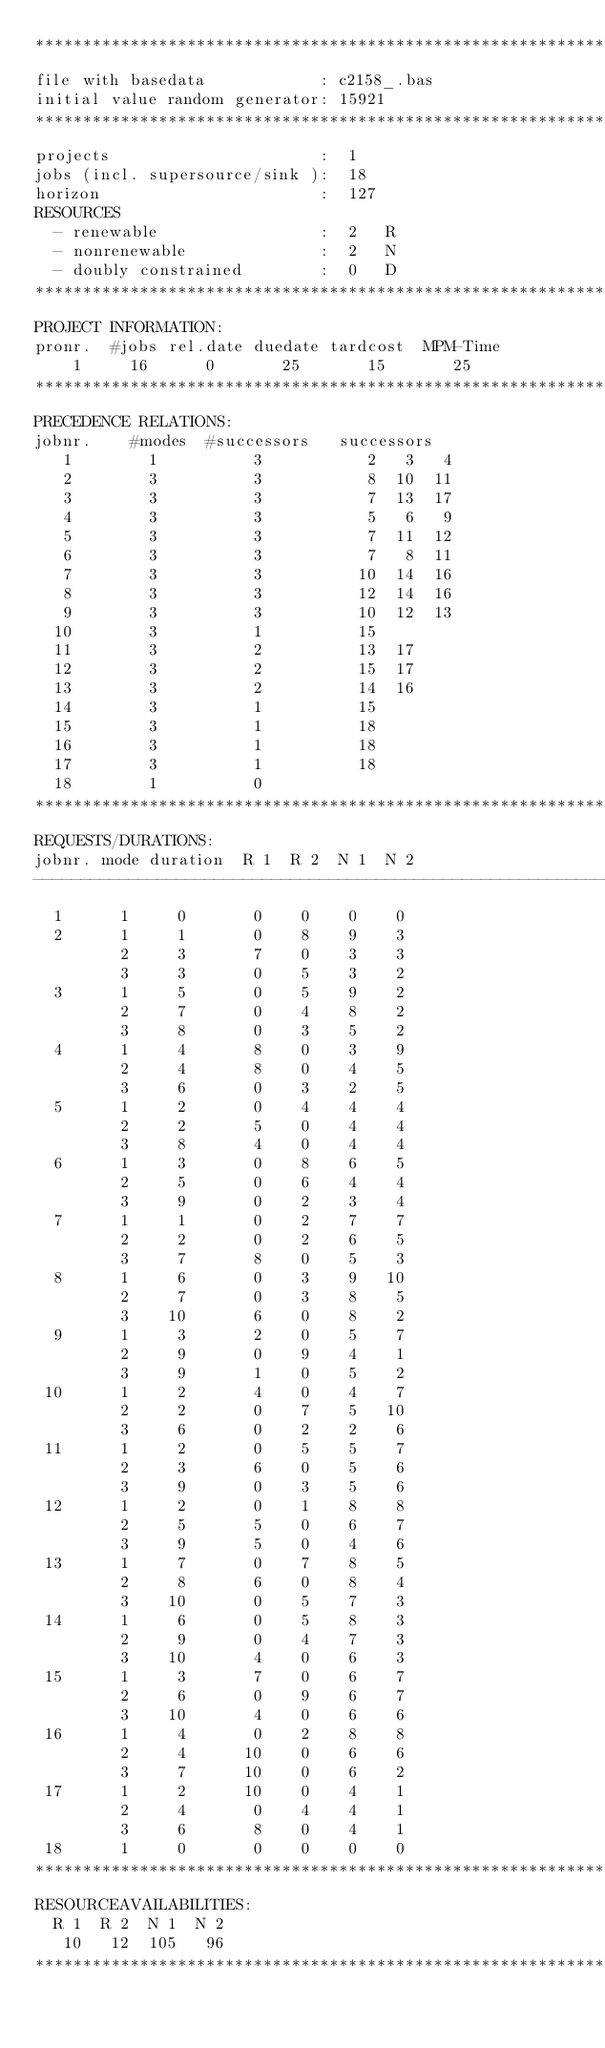Convert code to text. <code><loc_0><loc_0><loc_500><loc_500><_ObjectiveC_>************************************************************************
file with basedata            : c2158_.bas
initial value random generator: 15921
************************************************************************
projects                      :  1
jobs (incl. supersource/sink ):  18
horizon                       :  127
RESOURCES
  - renewable                 :  2   R
  - nonrenewable              :  2   N
  - doubly constrained        :  0   D
************************************************************************
PROJECT INFORMATION:
pronr.  #jobs rel.date duedate tardcost  MPM-Time
    1     16      0       25       15       25
************************************************************************
PRECEDENCE RELATIONS:
jobnr.    #modes  #successors   successors
   1        1          3           2   3   4
   2        3          3           8  10  11
   3        3          3           7  13  17
   4        3          3           5   6   9
   5        3          3           7  11  12
   6        3          3           7   8  11
   7        3          3          10  14  16
   8        3          3          12  14  16
   9        3          3          10  12  13
  10        3          1          15
  11        3          2          13  17
  12        3          2          15  17
  13        3          2          14  16
  14        3          1          15
  15        3          1          18
  16        3          1          18
  17        3          1          18
  18        1          0        
************************************************************************
REQUESTS/DURATIONS:
jobnr. mode duration  R 1  R 2  N 1  N 2
------------------------------------------------------------------------
  1      1     0       0    0    0    0
  2      1     1       0    8    9    3
         2     3       7    0    3    3
         3     3       0    5    3    2
  3      1     5       0    5    9    2
         2     7       0    4    8    2
         3     8       0    3    5    2
  4      1     4       8    0    3    9
         2     4       8    0    4    5
         3     6       0    3    2    5
  5      1     2       0    4    4    4
         2     2       5    0    4    4
         3     8       4    0    4    4
  6      1     3       0    8    6    5
         2     5       0    6    4    4
         3     9       0    2    3    4
  7      1     1       0    2    7    7
         2     2       0    2    6    5
         3     7       8    0    5    3
  8      1     6       0    3    9   10
         2     7       0    3    8    5
         3    10       6    0    8    2
  9      1     3       2    0    5    7
         2     9       0    9    4    1
         3     9       1    0    5    2
 10      1     2       4    0    4    7
         2     2       0    7    5   10
         3     6       0    2    2    6
 11      1     2       0    5    5    7
         2     3       6    0    5    6
         3     9       0    3    5    6
 12      1     2       0    1    8    8
         2     5       5    0    6    7
         3     9       5    0    4    6
 13      1     7       0    7    8    5
         2     8       6    0    8    4
         3    10       0    5    7    3
 14      1     6       0    5    8    3
         2     9       0    4    7    3
         3    10       4    0    6    3
 15      1     3       7    0    6    7
         2     6       0    9    6    7
         3    10       4    0    6    6
 16      1     4       0    2    8    8
         2     4      10    0    6    6
         3     7      10    0    6    2
 17      1     2      10    0    4    1
         2     4       0    4    4    1
         3     6       8    0    4    1
 18      1     0       0    0    0    0
************************************************************************
RESOURCEAVAILABILITIES:
  R 1  R 2  N 1  N 2
   10   12  105   96
************************************************************************
</code> 